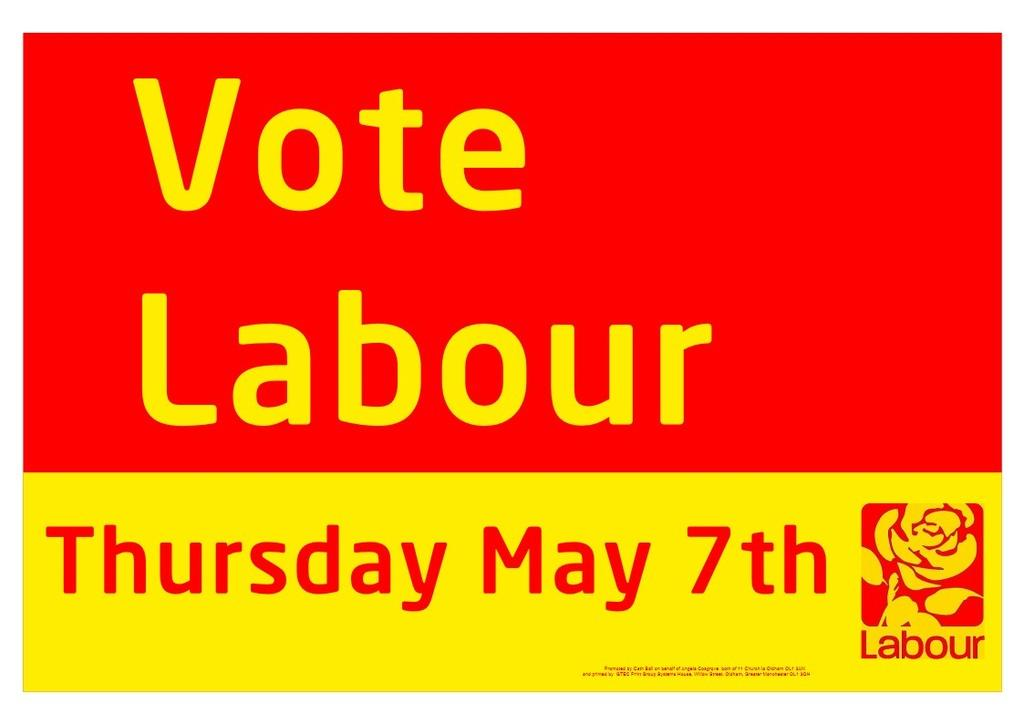What can be seen in the picture? There is a poster in the picture. What colors are used on the poster? The poster has red and yellow colors. What elements are present on the poster? There is a logo, a number, and words on the poster. What message does the poster convey about saying good-bye? There is no mention of good-bye in the image, as the focus is on the poster's colors, logo, number, and words. 